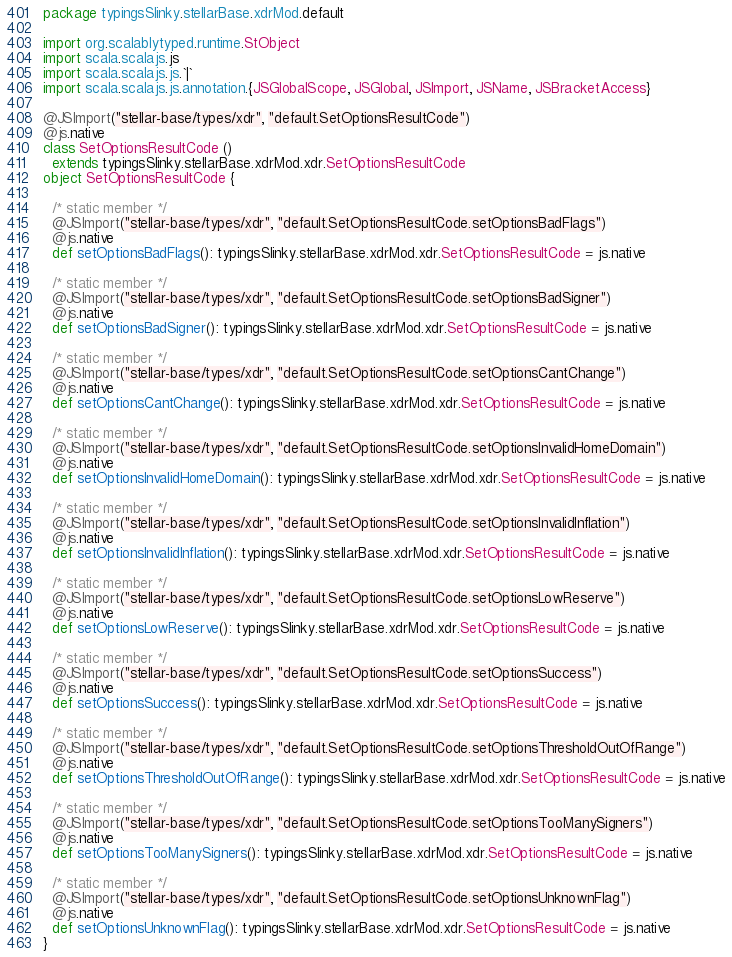<code> <loc_0><loc_0><loc_500><loc_500><_Scala_>package typingsSlinky.stellarBase.xdrMod.default

import org.scalablytyped.runtime.StObject
import scala.scalajs.js
import scala.scalajs.js.`|`
import scala.scalajs.js.annotation.{JSGlobalScope, JSGlobal, JSImport, JSName, JSBracketAccess}

@JSImport("stellar-base/types/xdr", "default.SetOptionsResultCode")
@js.native
class SetOptionsResultCode ()
  extends typingsSlinky.stellarBase.xdrMod.xdr.SetOptionsResultCode
object SetOptionsResultCode {
  
  /* static member */
  @JSImport("stellar-base/types/xdr", "default.SetOptionsResultCode.setOptionsBadFlags")
  @js.native
  def setOptionsBadFlags(): typingsSlinky.stellarBase.xdrMod.xdr.SetOptionsResultCode = js.native
  
  /* static member */
  @JSImport("stellar-base/types/xdr", "default.SetOptionsResultCode.setOptionsBadSigner")
  @js.native
  def setOptionsBadSigner(): typingsSlinky.stellarBase.xdrMod.xdr.SetOptionsResultCode = js.native
  
  /* static member */
  @JSImport("stellar-base/types/xdr", "default.SetOptionsResultCode.setOptionsCantChange")
  @js.native
  def setOptionsCantChange(): typingsSlinky.stellarBase.xdrMod.xdr.SetOptionsResultCode = js.native
  
  /* static member */
  @JSImport("stellar-base/types/xdr", "default.SetOptionsResultCode.setOptionsInvalidHomeDomain")
  @js.native
  def setOptionsInvalidHomeDomain(): typingsSlinky.stellarBase.xdrMod.xdr.SetOptionsResultCode = js.native
  
  /* static member */
  @JSImport("stellar-base/types/xdr", "default.SetOptionsResultCode.setOptionsInvalidInflation")
  @js.native
  def setOptionsInvalidInflation(): typingsSlinky.stellarBase.xdrMod.xdr.SetOptionsResultCode = js.native
  
  /* static member */
  @JSImport("stellar-base/types/xdr", "default.SetOptionsResultCode.setOptionsLowReserve")
  @js.native
  def setOptionsLowReserve(): typingsSlinky.stellarBase.xdrMod.xdr.SetOptionsResultCode = js.native
  
  /* static member */
  @JSImport("stellar-base/types/xdr", "default.SetOptionsResultCode.setOptionsSuccess")
  @js.native
  def setOptionsSuccess(): typingsSlinky.stellarBase.xdrMod.xdr.SetOptionsResultCode = js.native
  
  /* static member */
  @JSImport("stellar-base/types/xdr", "default.SetOptionsResultCode.setOptionsThresholdOutOfRange")
  @js.native
  def setOptionsThresholdOutOfRange(): typingsSlinky.stellarBase.xdrMod.xdr.SetOptionsResultCode = js.native
  
  /* static member */
  @JSImport("stellar-base/types/xdr", "default.SetOptionsResultCode.setOptionsTooManySigners")
  @js.native
  def setOptionsTooManySigners(): typingsSlinky.stellarBase.xdrMod.xdr.SetOptionsResultCode = js.native
  
  /* static member */
  @JSImport("stellar-base/types/xdr", "default.SetOptionsResultCode.setOptionsUnknownFlag")
  @js.native
  def setOptionsUnknownFlag(): typingsSlinky.stellarBase.xdrMod.xdr.SetOptionsResultCode = js.native
}
</code> 